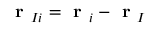<formula> <loc_0><loc_0><loc_500><loc_500>r _ { I i } = r _ { i } - r _ { I }</formula> 